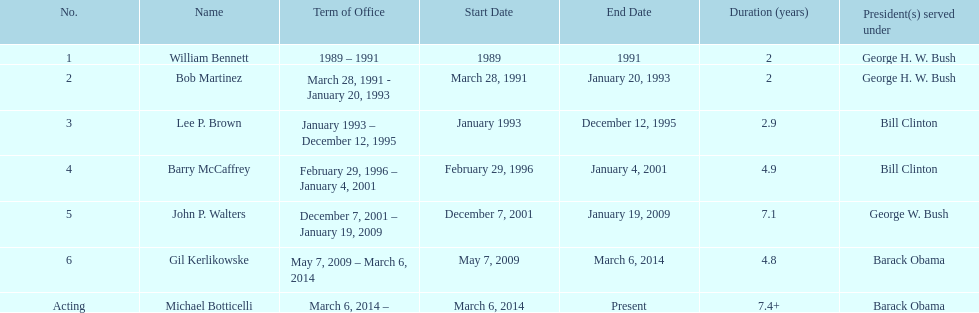How long did bob martinez serve as director? 2 years. 